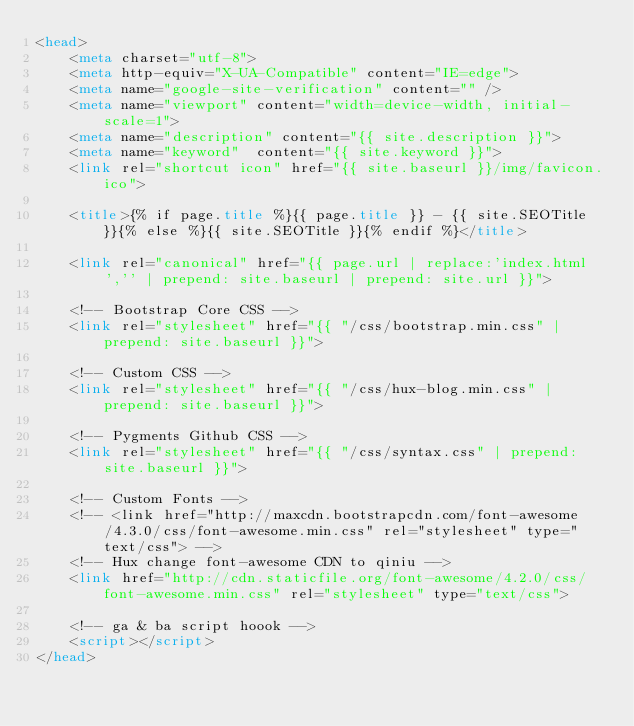<code> <loc_0><loc_0><loc_500><loc_500><_HTML_><head>
    <meta charset="utf-8">
    <meta http-equiv="X-UA-Compatible" content="IE=edge">
    <meta name="google-site-verification" content="" />
    <meta name="viewport" content="width=device-width, initial-scale=1">
    <meta name="description" content="{{ site.description }}">
    <meta name="keyword"  content="{{ site.keyword }}">
    <link rel="shortcut icon" href="{{ site.baseurl }}/img/favicon.ico">

    <title>{% if page.title %}{{ page.title }} - {{ site.SEOTitle }}{% else %}{{ site.SEOTitle }}{% endif %}</title>

    <link rel="canonical" href="{{ page.url | replace:'index.html','' | prepend: site.baseurl | prepend: site.url }}">

    <!-- Bootstrap Core CSS -->
    <link rel="stylesheet" href="{{ "/css/bootstrap.min.css" | prepend: site.baseurl }}">

    <!-- Custom CSS -->
    <link rel="stylesheet" href="{{ "/css/hux-blog.min.css" | prepend: site.baseurl }}">

    <!-- Pygments Github CSS -->
    <link rel="stylesheet" href="{{ "/css/syntax.css" | prepend: site.baseurl }}">

    <!-- Custom Fonts -->
    <!-- <link href="http://maxcdn.bootstrapcdn.com/font-awesome/4.3.0/css/font-awesome.min.css" rel="stylesheet" type="text/css"> -->
    <!-- Hux change font-awesome CDN to qiniu -->
    <link href="http://cdn.staticfile.org/font-awesome/4.2.0/css/font-awesome.min.css" rel="stylesheet" type="text/css">

    <!-- ga & ba script hoook -->
    <script></script>
</head>
</code> 